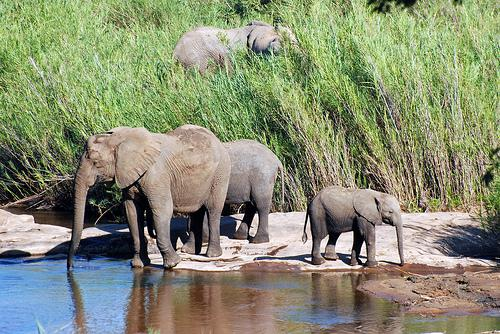Question: when do elephants get water?
Choices:
A. When they want to bathe.
B. When they are thirsty.
C. When the want to play.
D. When they migrate.
Answer with the letter. Answer: B Question: where are the elephants?
Choices:
A. The plains.
B. The savanna.
C. Watering hole.
D. The river.
Answer with the letter. Answer: C Question: how many elephants are in the picture?
Choices:
A. 5.
B. 2.
C. 4.
D. 3.
Answer with the letter. Answer: C Question: what color are elephants?
Choices:
A. Grey.
B. Brown.
C. Black.
D. White.
Answer with the letter. Answer: A Question: what do these elephants not have that most do?
Choices:
A. Large ears.
B. Tusks.
C. Eyes.
D. Grey skin.
Answer with the letter. Answer: B 